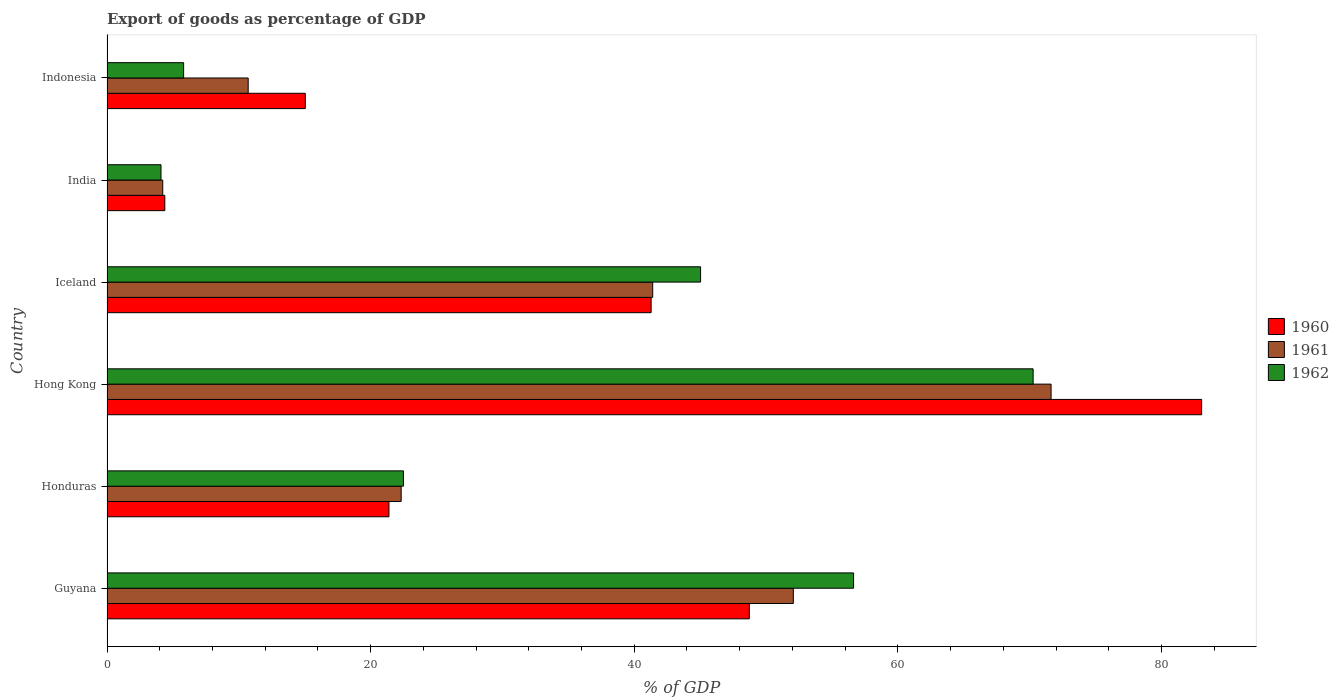How many groups of bars are there?
Your answer should be very brief. 6. How many bars are there on the 6th tick from the top?
Your answer should be compact. 3. How many bars are there on the 2nd tick from the bottom?
Ensure brevity in your answer.  3. What is the label of the 6th group of bars from the top?
Provide a short and direct response. Guyana. In how many cases, is the number of bars for a given country not equal to the number of legend labels?
Your response must be concise. 0. What is the export of goods as percentage of GDP in 1961 in Honduras?
Offer a very short reply. 22.32. Across all countries, what is the maximum export of goods as percentage of GDP in 1961?
Ensure brevity in your answer.  71.63. Across all countries, what is the minimum export of goods as percentage of GDP in 1961?
Provide a succinct answer. 4.23. In which country was the export of goods as percentage of GDP in 1962 maximum?
Your response must be concise. Hong Kong. In which country was the export of goods as percentage of GDP in 1962 minimum?
Make the answer very short. India. What is the total export of goods as percentage of GDP in 1960 in the graph?
Provide a succinct answer. 213.89. What is the difference between the export of goods as percentage of GDP in 1962 in Hong Kong and that in Indonesia?
Ensure brevity in your answer.  64.45. What is the difference between the export of goods as percentage of GDP in 1961 in Honduras and the export of goods as percentage of GDP in 1962 in Iceland?
Your answer should be very brief. -22.72. What is the average export of goods as percentage of GDP in 1961 per country?
Ensure brevity in your answer.  33.73. What is the difference between the export of goods as percentage of GDP in 1962 and export of goods as percentage of GDP in 1960 in Hong Kong?
Offer a terse response. -12.78. In how many countries, is the export of goods as percentage of GDP in 1962 greater than 20 %?
Ensure brevity in your answer.  4. What is the ratio of the export of goods as percentage of GDP in 1962 in Guyana to that in India?
Offer a terse response. 13.82. Is the difference between the export of goods as percentage of GDP in 1962 in Hong Kong and Iceland greater than the difference between the export of goods as percentage of GDP in 1960 in Hong Kong and Iceland?
Offer a very short reply. No. What is the difference between the highest and the second highest export of goods as percentage of GDP in 1960?
Provide a short and direct response. 34.32. What is the difference between the highest and the lowest export of goods as percentage of GDP in 1962?
Ensure brevity in your answer.  66.17. Is it the case that in every country, the sum of the export of goods as percentage of GDP in 1960 and export of goods as percentage of GDP in 1961 is greater than the export of goods as percentage of GDP in 1962?
Provide a succinct answer. Yes. How many bars are there?
Keep it short and to the point. 18. Are all the bars in the graph horizontal?
Make the answer very short. Yes. How many countries are there in the graph?
Make the answer very short. 6. What is the difference between two consecutive major ticks on the X-axis?
Make the answer very short. 20. Where does the legend appear in the graph?
Your response must be concise. Center right. What is the title of the graph?
Your answer should be very brief. Export of goods as percentage of GDP. What is the label or title of the X-axis?
Offer a terse response. % of GDP. What is the label or title of the Y-axis?
Provide a short and direct response. Country. What is the % of GDP in 1960 in Guyana?
Your answer should be very brief. 48.73. What is the % of GDP in 1961 in Guyana?
Your response must be concise. 52.07. What is the % of GDP of 1962 in Guyana?
Ensure brevity in your answer.  56.64. What is the % of GDP of 1960 in Honduras?
Your response must be concise. 21.39. What is the % of GDP in 1961 in Honduras?
Your answer should be compact. 22.32. What is the % of GDP in 1962 in Honduras?
Keep it short and to the point. 22.49. What is the % of GDP of 1960 in Hong Kong?
Give a very brief answer. 83.05. What is the % of GDP in 1961 in Hong Kong?
Make the answer very short. 71.63. What is the % of GDP in 1962 in Hong Kong?
Keep it short and to the point. 70.26. What is the % of GDP in 1960 in Iceland?
Offer a terse response. 41.28. What is the % of GDP of 1961 in Iceland?
Offer a very short reply. 41.4. What is the % of GDP in 1962 in Iceland?
Your answer should be very brief. 45.03. What is the % of GDP of 1960 in India?
Offer a terse response. 4.39. What is the % of GDP in 1961 in India?
Provide a short and direct response. 4.23. What is the % of GDP of 1962 in India?
Provide a succinct answer. 4.1. What is the % of GDP in 1960 in Indonesia?
Offer a terse response. 15.04. What is the % of GDP in 1961 in Indonesia?
Provide a short and direct response. 10.71. What is the % of GDP in 1962 in Indonesia?
Your answer should be very brief. 5.81. Across all countries, what is the maximum % of GDP of 1960?
Provide a short and direct response. 83.05. Across all countries, what is the maximum % of GDP of 1961?
Ensure brevity in your answer.  71.63. Across all countries, what is the maximum % of GDP in 1962?
Make the answer very short. 70.26. Across all countries, what is the minimum % of GDP of 1960?
Your answer should be compact. 4.39. Across all countries, what is the minimum % of GDP in 1961?
Your answer should be very brief. 4.23. Across all countries, what is the minimum % of GDP in 1962?
Your response must be concise. 4.1. What is the total % of GDP in 1960 in the graph?
Keep it short and to the point. 213.89. What is the total % of GDP of 1961 in the graph?
Ensure brevity in your answer.  202.36. What is the total % of GDP in 1962 in the graph?
Provide a short and direct response. 204.34. What is the difference between the % of GDP of 1960 in Guyana and that in Honduras?
Your answer should be very brief. 27.34. What is the difference between the % of GDP of 1961 in Guyana and that in Honduras?
Your answer should be compact. 29.75. What is the difference between the % of GDP in 1962 in Guyana and that in Honduras?
Your answer should be compact. 34.15. What is the difference between the % of GDP in 1960 in Guyana and that in Hong Kong?
Your response must be concise. -34.32. What is the difference between the % of GDP of 1961 in Guyana and that in Hong Kong?
Ensure brevity in your answer.  -19.55. What is the difference between the % of GDP of 1962 in Guyana and that in Hong Kong?
Provide a succinct answer. -13.62. What is the difference between the % of GDP in 1960 in Guyana and that in Iceland?
Give a very brief answer. 7.45. What is the difference between the % of GDP in 1961 in Guyana and that in Iceland?
Make the answer very short. 10.67. What is the difference between the % of GDP of 1962 in Guyana and that in Iceland?
Your answer should be compact. 11.61. What is the difference between the % of GDP in 1960 in Guyana and that in India?
Provide a succinct answer. 44.35. What is the difference between the % of GDP of 1961 in Guyana and that in India?
Offer a terse response. 47.84. What is the difference between the % of GDP of 1962 in Guyana and that in India?
Give a very brief answer. 52.55. What is the difference between the % of GDP of 1960 in Guyana and that in Indonesia?
Your response must be concise. 33.69. What is the difference between the % of GDP in 1961 in Guyana and that in Indonesia?
Your answer should be very brief. 41.36. What is the difference between the % of GDP in 1962 in Guyana and that in Indonesia?
Offer a terse response. 50.83. What is the difference between the % of GDP of 1960 in Honduras and that in Hong Kong?
Make the answer very short. -61.66. What is the difference between the % of GDP of 1961 in Honduras and that in Hong Kong?
Give a very brief answer. -49.31. What is the difference between the % of GDP in 1962 in Honduras and that in Hong Kong?
Keep it short and to the point. -47.78. What is the difference between the % of GDP in 1960 in Honduras and that in Iceland?
Your answer should be very brief. -19.89. What is the difference between the % of GDP of 1961 in Honduras and that in Iceland?
Offer a very short reply. -19.08. What is the difference between the % of GDP in 1962 in Honduras and that in Iceland?
Provide a succinct answer. -22.55. What is the difference between the % of GDP of 1960 in Honduras and that in India?
Ensure brevity in your answer.  17.01. What is the difference between the % of GDP in 1961 in Honduras and that in India?
Your answer should be compact. 18.09. What is the difference between the % of GDP in 1962 in Honduras and that in India?
Your answer should be very brief. 18.39. What is the difference between the % of GDP in 1960 in Honduras and that in Indonesia?
Keep it short and to the point. 6.35. What is the difference between the % of GDP in 1961 in Honduras and that in Indonesia?
Offer a very short reply. 11.61. What is the difference between the % of GDP in 1962 in Honduras and that in Indonesia?
Provide a short and direct response. 16.68. What is the difference between the % of GDP in 1960 in Hong Kong and that in Iceland?
Make the answer very short. 41.77. What is the difference between the % of GDP of 1961 in Hong Kong and that in Iceland?
Provide a short and direct response. 30.22. What is the difference between the % of GDP of 1962 in Hong Kong and that in Iceland?
Ensure brevity in your answer.  25.23. What is the difference between the % of GDP of 1960 in Hong Kong and that in India?
Give a very brief answer. 78.66. What is the difference between the % of GDP of 1961 in Hong Kong and that in India?
Your answer should be very brief. 67.4. What is the difference between the % of GDP in 1962 in Hong Kong and that in India?
Offer a very short reply. 66.17. What is the difference between the % of GDP in 1960 in Hong Kong and that in Indonesia?
Your response must be concise. 68.01. What is the difference between the % of GDP of 1961 in Hong Kong and that in Indonesia?
Ensure brevity in your answer.  60.92. What is the difference between the % of GDP of 1962 in Hong Kong and that in Indonesia?
Provide a short and direct response. 64.45. What is the difference between the % of GDP in 1960 in Iceland and that in India?
Offer a terse response. 36.9. What is the difference between the % of GDP in 1961 in Iceland and that in India?
Provide a succinct answer. 37.17. What is the difference between the % of GDP in 1962 in Iceland and that in India?
Give a very brief answer. 40.94. What is the difference between the % of GDP of 1960 in Iceland and that in Indonesia?
Offer a terse response. 26.24. What is the difference between the % of GDP of 1961 in Iceland and that in Indonesia?
Your answer should be compact. 30.69. What is the difference between the % of GDP of 1962 in Iceland and that in Indonesia?
Keep it short and to the point. 39.22. What is the difference between the % of GDP in 1960 in India and that in Indonesia?
Offer a terse response. -10.66. What is the difference between the % of GDP of 1961 in India and that in Indonesia?
Give a very brief answer. -6.48. What is the difference between the % of GDP in 1962 in India and that in Indonesia?
Your response must be concise. -1.72. What is the difference between the % of GDP in 1960 in Guyana and the % of GDP in 1961 in Honduras?
Your answer should be very brief. 26.41. What is the difference between the % of GDP of 1960 in Guyana and the % of GDP of 1962 in Honduras?
Provide a short and direct response. 26.24. What is the difference between the % of GDP in 1961 in Guyana and the % of GDP in 1962 in Honduras?
Ensure brevity in your answer.  29.58. What is the difference between the % of GDP of 1960 in Guyana and the % of GDP of 1961 in Hong Kong?
Offer a very short reply. -22.89. What is the difference between the % of GDP in 1960 in Guyana and the % of GDP in 1962 in Hong Kong?
Provide a short and direct response. -21.53. What is the difference between the % of GDP of 1961 in Guyana and the % of GDP of 1962 in Hong Kong?
Offer a terse response. -18.19. What is the difference between the % of GDP of 1960 in Guyana and the % of GDP of 1961 in Iceland?
Offer a very short reply. 7.33. What is the difference between the % of GDP of 1960 in Guyana and the % of GDP of 1962 in Iceland?
Offer a very short reply. 3.7. What is the difference between the % of GDP in 1961 in Guyana and the % of GDP in 1962 in Iceland?
Ensure brevity in your answer.  7.04. What is the difference between the % of GDP in 1960 in Guyana and the % of GDP in 1961 in India?
Ensure brevity in your answer.  44.5. What is the difference between the % of GDP in 1960 in Guyana and the % of GDP in 1962 in India?
Give a very brief answer. 44.63. What is the difference between the % of GDP in 1961 in Guyana and the % of GDP in 1962 in India?
Make the answer very short. 47.97. What is the difference between the % of GDP in 1960 in Guyana and the % of GDP in 1961 in Indonesia?
Your answer should be very brief. 38.02. What is the difference between the % of GDP of 1960 in Guyana and the % of GDP of 1962 in Indonesia?
Make the answer very short. 42.92. What is the difference between the % of GDP of 1961 in Guyana and the % of GDP of 1962 in Indonesia?
Offer a terse response. 46.26. What is the difference between the % of GDP of 1960 in Honduras and the % of GDP of 1961 in Hong Kong?
Provide a succinct answer. -50.23. What is the difference between the % of GDP of 1960 in Honduras and the % of GDP of 1962 in Hong Kong?
Make the answer very short. -48.87. What is the difference between the % of GDP of 1961 in Honduras and the % of GDP of 1962 in Hong Kong?
Offer a terse response. -47.95. What is the difference between the % of GDP of 1960 in Honduras and the % of GDP of 1961 in Iceland?
Ensure brevity in your answer.  -20.01. What is the difference between the % of GDP in 1960 in Honduras and the % of GDP in 1962 in Iceland?
Your response must be concise. -23.64. What is the difference between the % of GDP of 1961 in Honduras and the % of GDP of 1962 in Iceland?
Ensure brevity in your answer.  -22.72. What is the difference between the % of GDP of 1960 in Honduras and the % of GDP of 1961 in India?
Provide a succinct answer. 17.16. What is the difference between the % of GDP of 1960 in Honduras and the % of GDP of 1962 in India?
Your answer should be very brief. 17.29. What is the difference between the % of GDP of 1961 in Honduras and the % of GDP of 1962 in India?
Make the answer very short. 18.22. What is the difference between the % of GDP of 1960 in Honduras and the % of GDP of 1961 in Indonesia?
Your response must be concise. 10.68. What is the difference between the % of GDP of 1960 in Honduras and the % of GDP of 1962 in Indonesia?
Offer a terse response. 15.58. What is the difference between the % of GDP in 1961 in Honduras and the % of GDP in 1962 in Indonesia?
Give a very brief answer. 16.51. What is the difference between the % of GDP in 1960 in Hong Kong and the % of GDP in 1961 in Iceland?
Ensure brevity in your answer.  41.65. What is the difference between the % of GDP of 1960 in Hong Kong and the % of GDP of 1962 in Iceland?
Your response must be concise. 38.01. What is the difference between the % of GDP in 1961 in Hong Kong and the % of GDP in 1962 in Iceland?
Offer a terse response. 26.59. What is the difference between the % of GDP of 1960 in Hong Kong and the % of GDP of 1961 in India?
Provide a short and direct response. 78.82. What is the difference between the % of GDP in 1960 in Hong Kong and the % of GDP in 1962 in India?
Offer a terse response. 78.95. What is the difference between the % of GDP in 1961 in Hong Kong and the % of GDP in 1962 in India?
Provide a succinct answer. 67.53. What is the difference between the % of GDP of 1960 in Hong Kong and the % of GDP of 1961 in Indonesia?
Make the answer very short. 72.34. What is the difference between the % of GDP in 1960 in Hong Kong and the % of GDP in 1962 in Indonesia?
Ensure brevity in your answer.  77.24. What is the difference between the % of GDP of 1961 in Hong Kong and the % of GDP of 1962 in Indonesia?
Give a very brief answer. 65.81. What is the difference between the % of GDP in 1960 in Iceland and the % of GDP in 1961 in India?
Ensure brevity in your answer.  37.05. What is the difference between the % of GDP in 1960 in Iceland and the % of GDP in 1962 in India?
Your response must be concise. 37.19. What is the difference between the % of GDP of 1961 in Iceland and the % of GDP of 1962 in India?
Provide a short and direct response. 37.3. What is the difference between the % of GDP of 1960 in Iceland and the % of GDP of 1961 in Indonesia?
Your response must be concise. 30.57. What is the difference between the % of GDP in 1960 in Iceland and the % of GDP in 1962 in Indonesia?
Your response must be concise. 35.47. What is the difference between the % of GDP in 1961 in Iceland and the % of GDP in 1962 in Indonesia?
Keep it short and to the point. 35.59. What is the difference between the % of GDP of 1960 in India and the % of GDP of 1961 in Indonesia?
Provide a short and direct response. -6.32. What is the difference between the % of GDP in 1960 in India and the % of GDP in 1962 in Indonesia?
Ensure brevity in your answer.  -1.43. What is the difference between the % of GDP in 1961 in India and the % of GDP in 1962 in Indonesia?
Your answer should be compact. -1.58. What is the average % of GDP of 1960 per country?
Your answer should be very brief. 35.65. What is the average % of GDP of 1961 per country?
Your answer should be compact. 33.73. What is the average % of GDP of 1962 per country?
Offer a terse response. 34.06. What is the difference between the % of GDP of 1960 and % of GDP of 1961 in Guyana?
Ensure brevity in your answer.  -3.34. What is the difference between the % of GDP of 1960 and % of GDP of 1962 in Guyana?
Your response must be concise. -7.91. What is the difference between the % of GDP of 1961 and % of GDP of 1962 in Guyana?
Ensure brevity in your answer.  -4.57. What is the difference between the % of GDP in 1960 and % of GDP in 1961 in Honduras?
Your response must be concise. -0.93. What is the difference between the % of GDP of 1960 and % of GDP of 1962 in Honduras?
Give a very brief answer. -1.1. What is the difference between the % of GDP in 1961 and % of GDP in 1962 in Honduras?
Offer a very short reply. -0.17. What is the difference between the % of GDP of 1960 and % of GDP of 1961 in Hong Kong?
Provide a succinct answer. 11.42. What is the difference between the % of GDP in 1960 and % of GDP in 1962 in Hong Kong?
Keep it short and to the point. 12.78. What is the difference between the % of GDP of 1961 and % of GDP of 1962 in Hong Kong?
Provide a succinct answer. 1.36. What is the difference between the % of GDP in 1960 and % of GDP in 1961 in Iceland?
Offer a very short reply. -0.12. What is the difference between the % of GDP of 1960 and % of GDP of 1962 in Iceland?
Give a very brief answer. -3.75. What is the difference between the % of GDP of 1961 and % of GDP of 1962 in Iceland?
Keep it short and to the point. -3.63. What is the difference between the % of GDP of 1960 and % of GDP of 1961 in India?
Keep it short and to the point. 0.16. What is the difference between the % of GDP of 1960 and % of GDP of 1962 in India?
Keep it short and to the point. 0.29. What is the difference between the % of GDP in 1961 and % of GDP in 1962 in India?
Give a very brief answer. 0.13. What is the difference between the % of GDP of 1960 and % of GDP of 1961 in Indonesia?
Your response must be concise. 4.33. What is the difference between the % of GDP in 1960 and % of GDP in 1962 in Indonesia?
Your answer should be compact. 9.23. What is the difference between the % of GDP in 1961 and % of GDP in 1962 in Indonesia?
Ensure brevity in your answer.  4.9. What is the ratio of the % of GDP of 1960 in Guyana to that in Honduras?
Offer a terse response. 2.28. What is the ratio of the % of GDP of 1961 in Guyana to that in Honduras?
Keep it short and to the point. 2.33. What is the ratio of the % of GDP in 1962 in Guyana to that in Honduras?
Your response must be concise. 2.52. What is the ratio of the % of GDP of 1960 in Guyana to that in Hong Kong?
Provide a succinct answer. 0.59. What is the ratio of the % of GDP in 1961 in Guyana to that in Hong Kong?
Provide a succinct answer. 0.73. What is the ratio of the % of GDP in 1962 in Guyana to that in Hong Kong?
Keep it short and to the point. 0.81. What is the ratio of the % of GDP in 1960 in Guyana to that in Iceland?
Offer a terse response. 1.18. What is the ratio of the % of GDP in 1961 in Guyana to that in Iceland?
Offer a terse response. 1.26. What is the ratio of the % of GDP of 1962 in Guyana to that in Iceland?
Make the answer very short. 1.26. What is the ratio of the % of GDP in 1960 in Guyana to that in India?
Your answer should be compact. 11.11. What is the ratio of the % of GDP in 1961 in Guyana to that in India?
Offer a terse response. 12.31. What is the ratio of the % of GDP of 1962 in Guyana to that in India?
Offer a very short reply. 13.82. What is the ratio of the % of GDP in 1960 in Guyana to that in Indonesia?
Provide a short and direct response. 3.24. What is the ratio of the % of GDP of 1961 in Guyana to that in Indonesia?
Ensure brevity in your answer.  4.86. What is the ratio of the % of GDP in 1962 in Guyana to that in Indonesia?
Your answer should be compact. 9.74. What is the ratio of the % of GDP of 1960 in Honduras to that in Hong Kong?
Make the answer very short. 0.26. What is the ratio of the % of GDP in 1961 in Honduras to that in Hong Kong?
Offer a very short reply. 0.31. What is the ratio of the % of GDP in 1962 in Honduras to that in Hong Kong?
Provide a succinct answer. 0.32. What is the ratio of the % of GDP of 1960 in Honduras to that in Iceland?
Your answer should be compact. 0.52. What is the ratio of the % of GDP in 1961 in Honduras to that in Iceland?
Give a very brief answer. 0.54. What is the ratio of the % of GDP in 1962 in Honduras to that in Iceland?
Your answer should be compact. 0.5. What is the ratio of the % of GDP of 1960 in Honduras to that in India?
Provide a short and direct response. 4.88. What is the ratio of the % of GDP in 1961 in Honduras to that in India?
Your answer should be very brief. 5.28. What is the ratio of the % of GDP in 1962 in Honduras to that in India?
Keep it short and to the point. 5.49. What is the ratio of the % of GDP of 1960 in Honduras to that in Indonesia?
Give a very brief answer. 1.42. What is the ratio of the % of GDP in 1961 in Honduras to that in Indonesia?
Your response must be concise. 2.08. What is the ratio of the % of GDP of 1962 in Honduras to that in Indonesia?
Your answer should be compact. 3.87. What is the ratio of the % of GDP of 1960 in Hong Kong to that in Iceland?
Ensure brevity in your answer.  2.01. What is the ratio of the % of GDP in 1961 in Hong Kong to that in Iceland?
Give a very brief answer. 1.73. What is the ratio of the % of GDP in 1962 in Hong Kong to that in Iceland?
Offer a very short reply. 1.56. What is the ratio of the % of GDP of 1960 in Hong Kong to that in India?
Offer a very short reply. 18.93. What is the ratio of the % of GDP in 1961 in Hong Kong to that in India?
Offer a terse response. 16.94. What is the ratio of the % of GDP in 1962 in Hong Kong to that in India?
Your answer should be very brief. 17.15. What is the ratio of the % of GDP in 1960 in Hong Kong to that in Indonesia?
Provide a short and direct response. 5.52. What is the ratio of the % of GDP of 1961 in Hong Kong to that in Indonesia?
Make the answer very short. 6.69. What is the ratio of the % of GDP of 1962 in Hong Kong to that in Indonesia?
Give a very brief answer. 12.09. What is the ratio of the % of GDP of 1960 in Iceland to that in India?
Offer a very short reply. 9.41. What is the ratio of the % of GDP in 1961 in Iceland to that in India?
Your answer should be compact. 9.79. What is the ratio of the % of GDP in 1962 in Iceland to that in India?
Give a very brief answer. 10.99. What is the ratio of the % of GDP of 1960 in Iceland to that in Indonesia?
Your answer should be compact. 2.74. What is the ratio of the % of GDP in 1961 in Iceland to that in Indonesia?
Provide a succinct answer. 3.87. What is the ratio of the % of GDP in 1962 in Iceland to that in Indonesia?
Keep it short and to the point. 7.75. What is the ratio of the % of GDP of 1960 in India to that in Indonesia?
Provide a short and direct response. 0.29. What is the ratio of the % of GDP of 1961 in India to that in Indonesia?
Your answer should be very brief. 0.39. What is the ratio of the % of GDP of 1962 in India to that in Indonesia?
Offer a terse response. 0.7. What is the difference between the highest and the second highest % of GDP of 1960?
Ensure brevity in your answer.  34.32. What is the difference between the highest and the second highest % of GDP of 1961?
Ensure brevity in your answer.  19.55. What is the difference between the highest and the second highest % of GDP of 1962?
Provide a succinct answer. 13.62. What is the difference between the highest and the lowest % of GDP of 1960?
Give a very brief answer. 78.66. What is the difference between the highest and the lowest % of GDP of 1961?
Provide a succinct answer. 67.4. What is the difference between the highest and the lowest % of GDP of 1962?
Give a very brief answer. 66.17. 